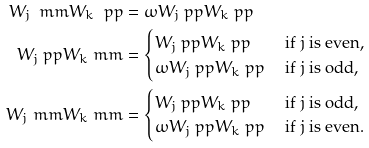Convert formula to latex. <formula><loc_0><loc_0><loc_500><loc_500>W _ { j } \ m m W _ { k } \ p p & = \omega W _ { j } \ p p W _ { k } \ p p \\ W _ { j } \ p p W _ { k } \ m m & = \begin{cases} W _ { j } \ p p W _ { k } \ p p & \text { if } j \text { is even,} \\ \omega W _ { j } \ p p W _ { k } \ p p & \text { if } j \text { is odd,} \end{cases} \\ W _ { j } \ m m W _ { k } \ m m & = \begin{cases} W _ { j } \ p p W _ { k } \ p p & \text { if } j \text { is odd,} \\ \omega W _ { j } \ p p W _ { k } \ p p & \text { if } j \text { is even.} \end{cases}</formula> 